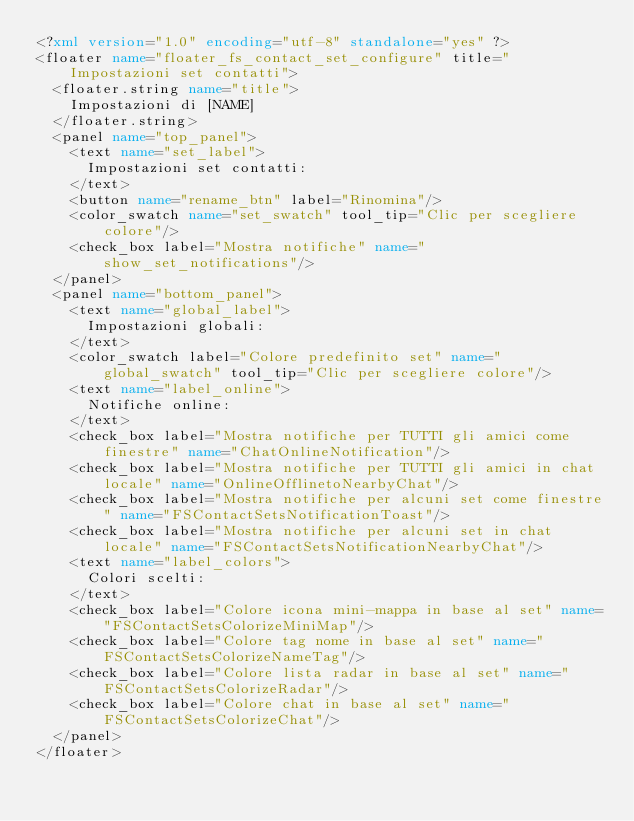<code> <loc_0><loc_0><loc_500><loc_500><_XML_><?xml version="1.0" encoding="utf-8" standalone="yes" ?>
<floater name="floater_fs_contact_set_configure" title="Impostazioni set contatti">
	<floater.string name="title">
		Impostazioni di [NAME]
	</floater.string>
	<panel name="top_panel">
		<text name="set_label">
			Impostazioni set contatti:
		</text>
		<button name="rename_btn" label="Rinomina"/>
		<color_swatch name="set_swatch" tool_tip="Clic per scegliere colore"/>
		<check_box label="Mostra notifiche" name="show_set_notifications"/>
	</panel>
	<panel name="bottom_panel">
		<text name="global_label">
			Impostazioni globali:
		</text>
		<color_swatch label="Colore predefinito set" name="global_swatch" tool_tip="Clic per scegliere colore"/>
		<text name="label_online">
			Notifiche online:
		</text>
		<check_box label="Mostra notifiche per TUTTI gli amici come finestre" name="ChatOnlineNotification"/>
		<check_box label="Mostra notifiche per TUTTI gli amici in chat locale" name="OnlineOfflinetoNearbyChat"/>
		<check_box label="Mostra notifiche per alcuni set come finestre" name="FSContactSetsNotificationToast"/>
		<check_box label="Mostra notifiche per alcuni set in chat locale" name="FSContactSetsNotificationNearbyChat"/>
		<text name="label_colors">
			Colori scelti:
		</text>
		<check_box label="Colore icona mini-mappa in base al set" name="FSContactSetsColorizeMiniMap"/>
		<check_box label="Colore tag nome in base al set" name="FSContactSetsColorizeNameTag"/>
		<check_box label="Colore lista radar in base al set" name="FSContactSetsColorizeRadar"/>
		<check_box label="Colore chat in base al set" name="FSContactSetsColorizeChat"/>
	</panel>
</floater>
</code> 